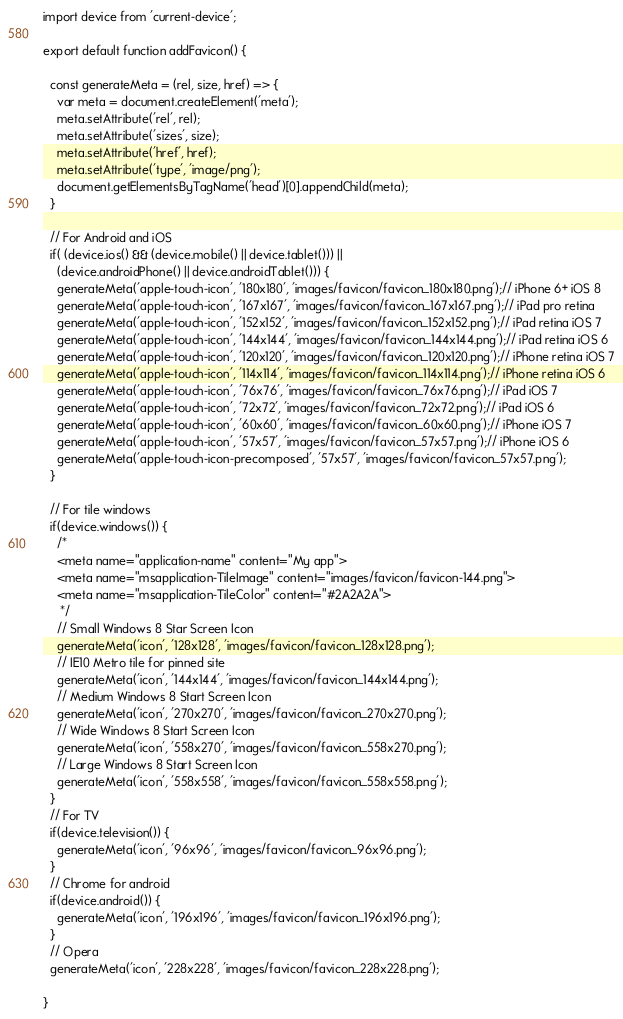Convert code to text. <code><loc_0><loc_0><loc_500><loc_500><_JavaScript_>import device from 'current-device';

export default function addFavicon() {

  const generateMeta = (rel, size, href) => {
    var meta = document.createElement('meta');
    meta.setAttribute('rel', rel);
    meta.setAttribute('sizes', size);
    meta.setAttribute('href', href);
    meta.setAttribute('type', 'image/png');
    document.getElementsByTagName('head')[0].appendChild(meta);
  }

  // For Android and iOS
  if( (device.ios() && (device.mobile() || device.tablet())) ||
    (device.androidPhone() || device.androidTablet())) {
    generateMeta('apple-touch-icon', '180x180', 'images/favicon/favicon_180x180.png');// iPhone 6+ iOS 8
    generateMeta('apple-touch-icon', '167x167', 'images/favicon/favicon_167x167.png');// iPad pro retina
    generateMeta('apple-touch-icon', '152x152', 'images/favicon/favicon_152x152.png');// iPad retina iOS 7
    generateMeta('apple-touch-icon', '144x144', 'images/favicon/favicon_144x144.png');// iPad retina iOS 6
    generateMeta('apple-touch-icon', '120x120', 'images/favicon/favicon_120x120.png');// iPhone retina iOS 7
    generateMeta('apple-touch-icon', '114x114', 'images/favicon/favicon_114x114.png');// iPhone retina iOS 6
    generateMeta('apple-touch-icon', '76x76', 'images/favicon/favicon_76x76.png');// iPad iOS 7
    generateMeta('apple-touch-icon', '72x72', 'images/favicon/favicon_72x72.png');// iPad iOS 6
    generateMeta('apple-touch-icon', '60x60', 'images/favicon/favicon_60x60.png');// iPhone iOS 7
    generateMeta('apple-touch-icon', '57x57', 'images/favicon/favicon_57x57.png');// iPhone iOS 6
    generateMeta('apple-touch-icon-precomposed', '57x57', 'images/favicon/favicon_57x57.png');
  }

  // For tile windows
  if(device.windows()) {
    /*
    <meta name="application-name" content="My app">
    <meta name="msapplication-TileImage" content="images/favicon/favicon-144.png">
    <meta name="msapplication-TileColor" content="#2A2A2A">
     */
    // Small Windows 8 Star Screen Icon
    generateMeta('icon', '128x128', 'images/favicon/favicon_128x128.png');
    // IE10 Metro tile for pinned site
    generateMeta('icon', '144x144', 'images/favicon/favicon_144x144.png');
    // Medium Windows 8 Start Screen Icon
    generateMeta('icon', '270x270', 'images/favicon/favicon_270x270.png');
    // Wide Windows 8 Start Screen Icon
    generateMeta('icon', '558x270', 'images/favicon/favicon_558x270.png');
    // Large Windows 8 Start Screen Icon
    generateMeta('icon', '558x558', 'images/favicon/favicon_558x558.png');
  }
  // For TV
  if(device.television()) {
    generateMeta('icon', '96x96', 'images/favicon/favicon_96x96.png');
  }
  // Chrome for android
  if(device.android()) {
    generateMeta('icon', '196x196', 'images/favicon/favicon_196x196.png');
  }
  // Opera
  generateMeta('icon', '228x228', 'images/favicon/favicon_228x228.png');

}</code> 